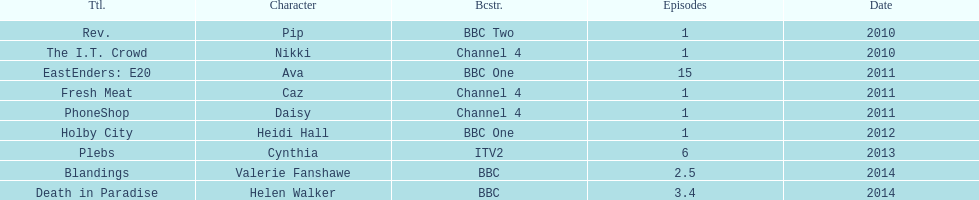What is the entire sum of shows with appearances by sophie colguhoun? 9. 